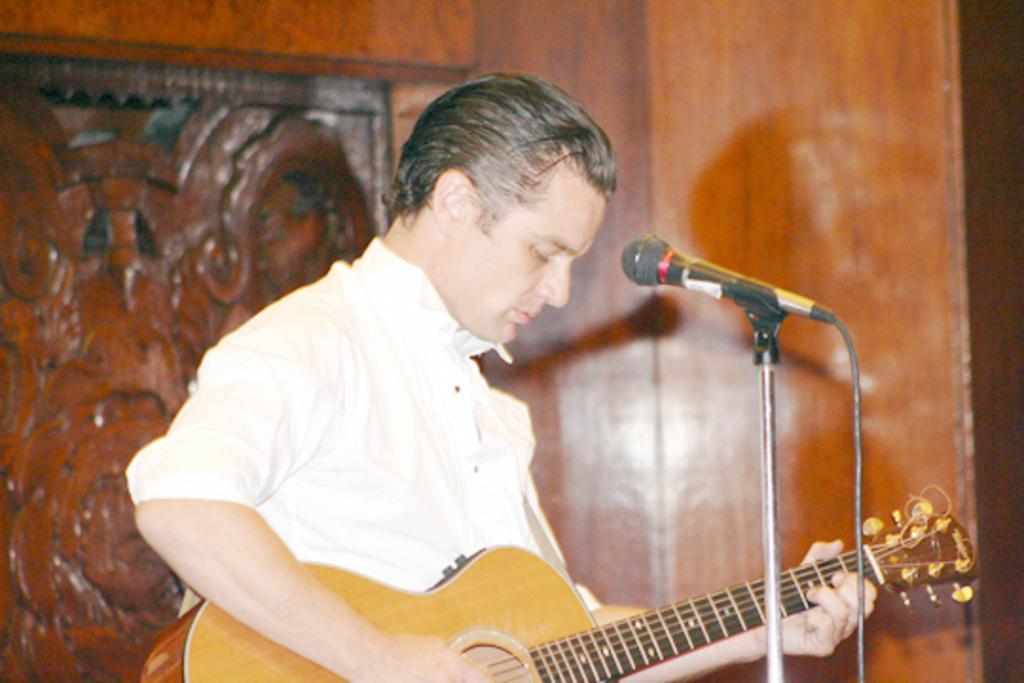Please provide a concise description of this image. In this picture there is a man and he is wearing a white shirt and playing a guitar. In front of him there is a mike. In the background there is a wooden wall. 